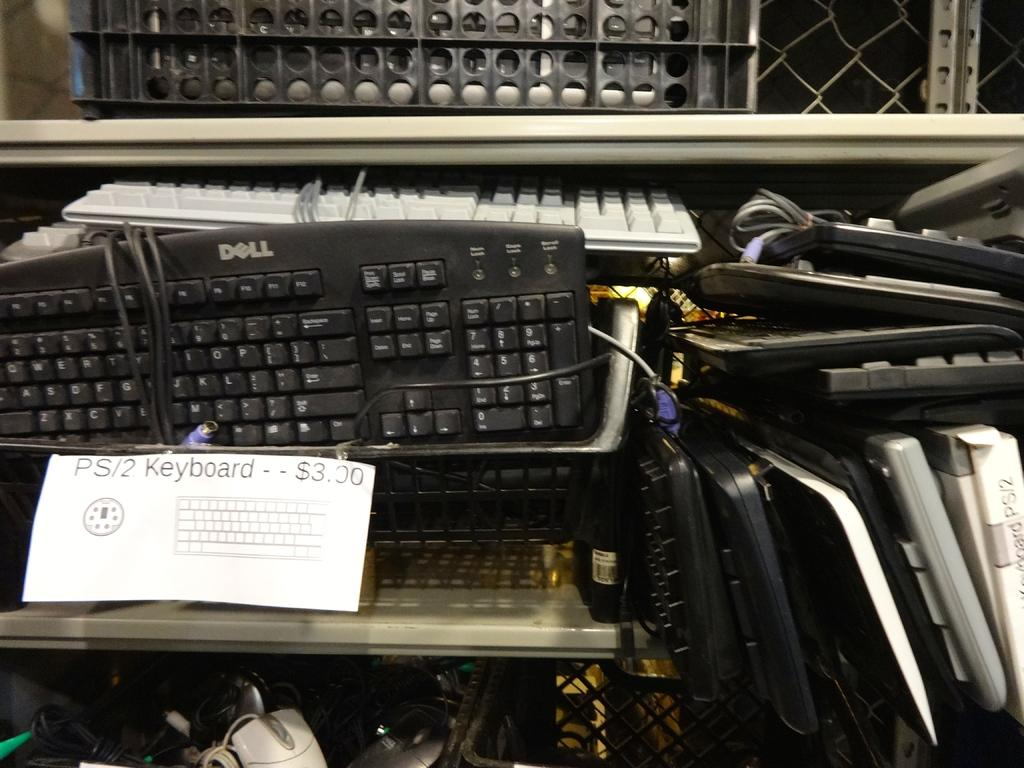<image>
Summarize the visual content of the image. The sign says that PS/2 keyboards are $3.00. 